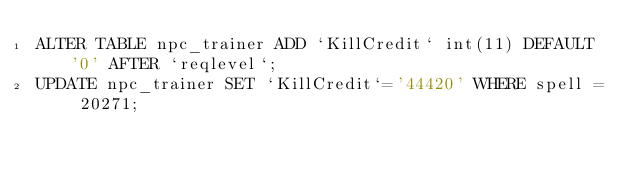Convert code to text. <code><loc_0><loc_0><loc_500><loc_500><_SQL_>ALTER TABLE npc_trainer ADD `KillCredit` int(11) DEFAULT '0' AFTER `reqlevel`;
UPDATE npc_trainer SET `KillCredit`='44420' WHERE spell = 20271;</code> 